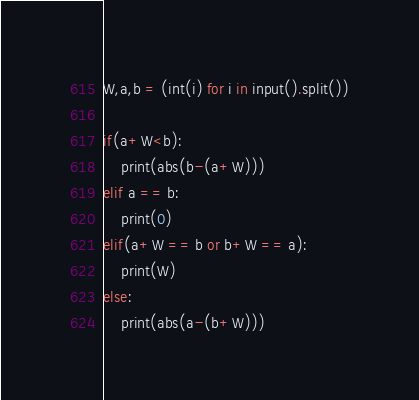<code> <loc_0><loc_0><loc_500><loc_500><_Python_>W,a,b = (int(i) for i in input().split())

if(a+W<b):
    print(abs(b-(a+W)))
elif a == b:
    print(0)
elif(a+W == b or b+W == a):
    print(W)
else:
    print(abs(a-(b+W)))</code> 